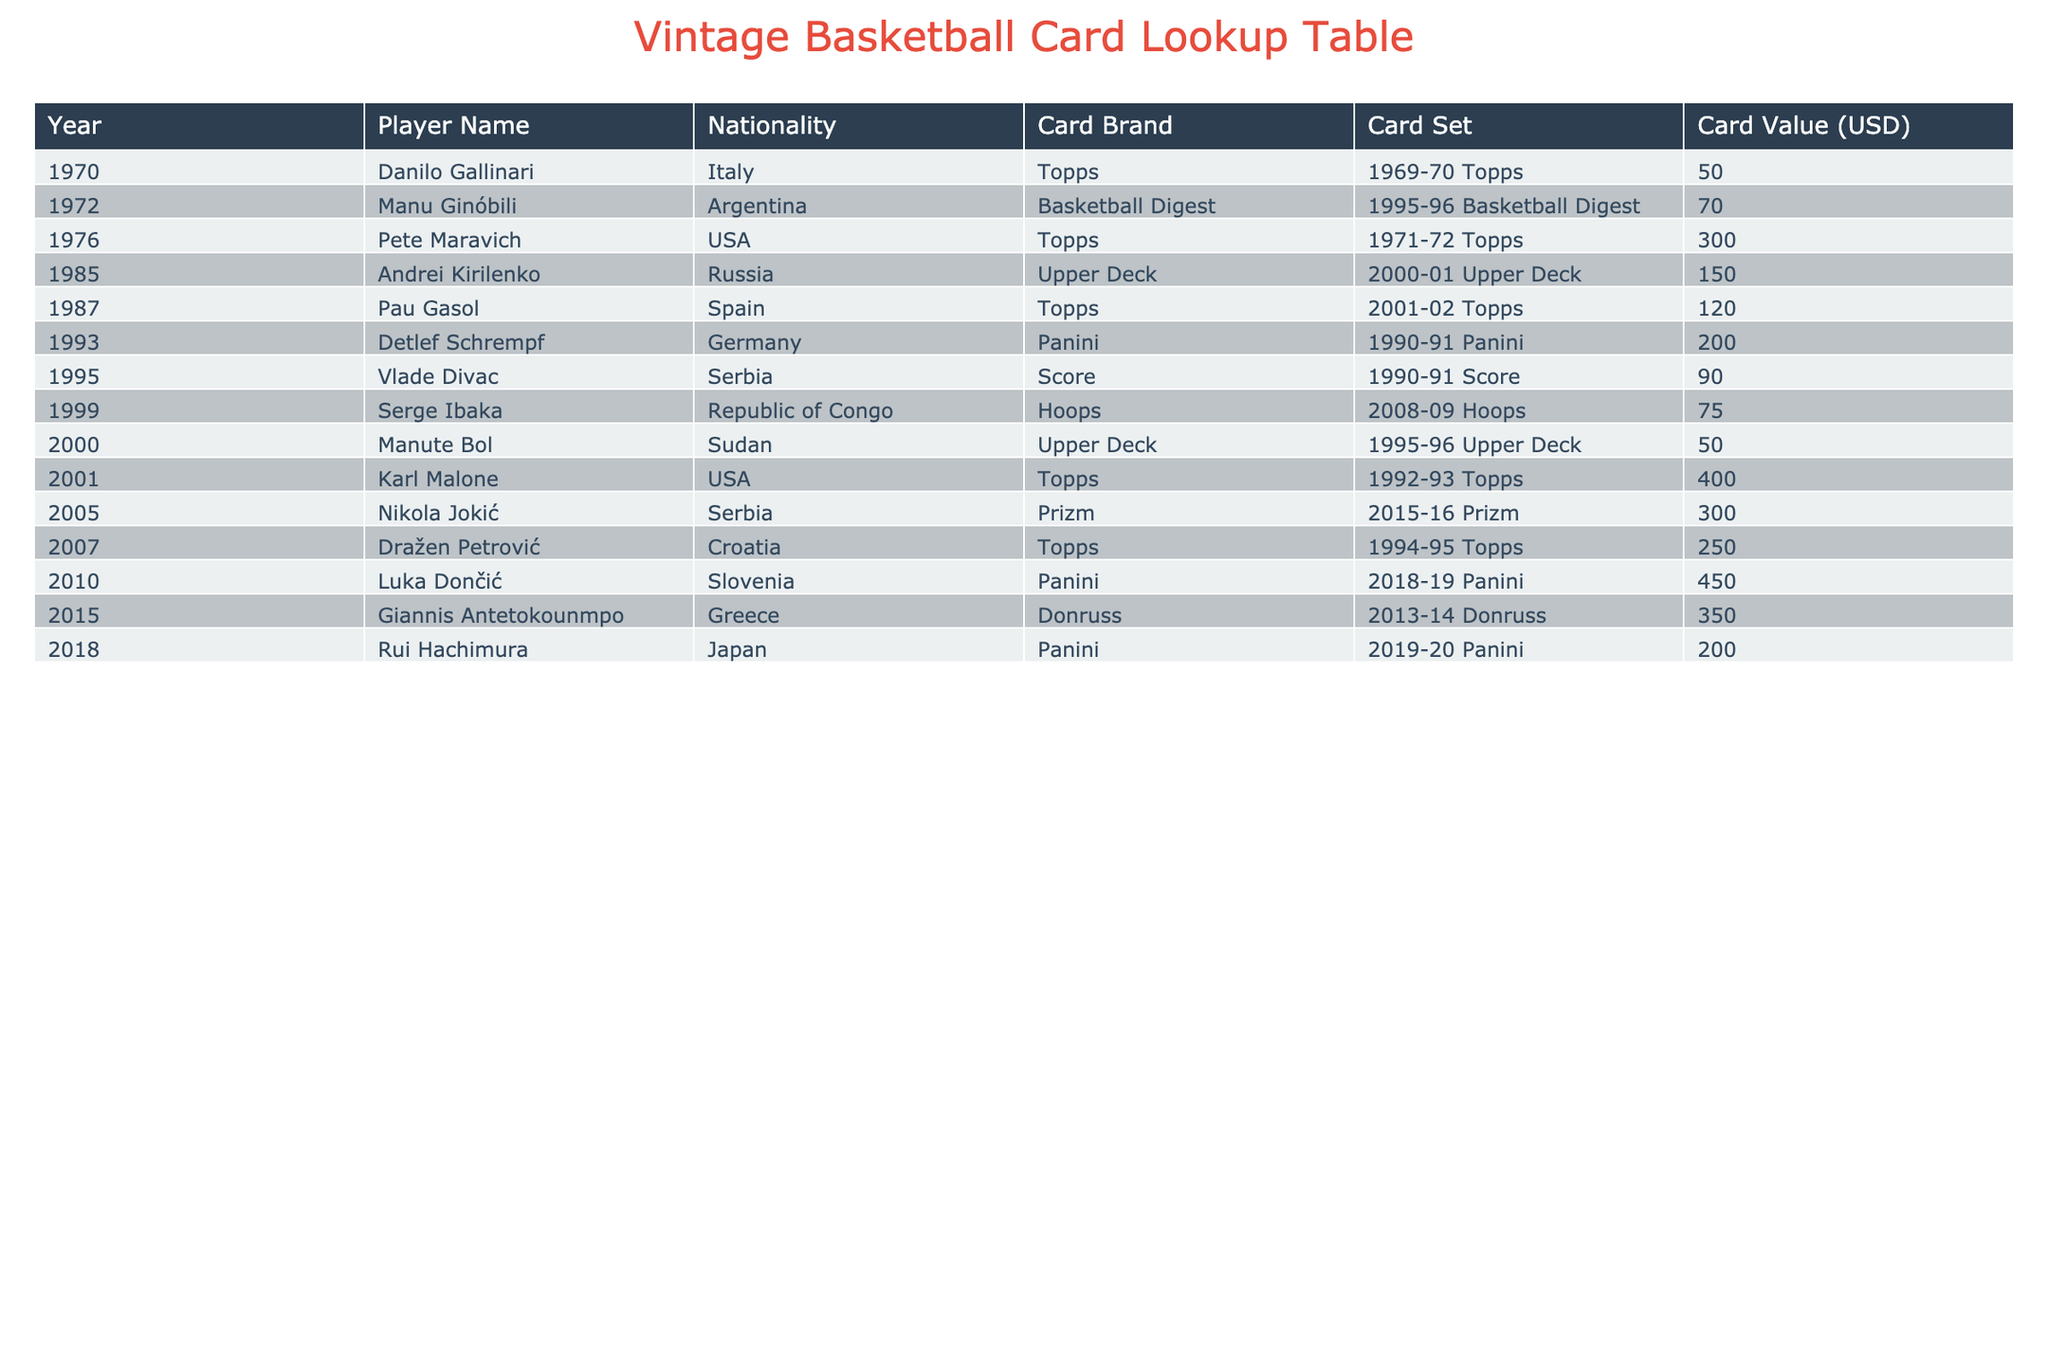What is the highest card value among international players? The highest card value from international players is found by looking at the "Card Value (USD)" column and identifying the maximum value. The highest value listed is 450 for Luka Dončić in 2010.
Answer: 450 Which player has the lowest card value in the table? To find the lowest card value, we can scan the "Card Value (USD)" column and identify the minimum value. The lowest value is 50, associated with Danilo Gallinari and Manute Bol.
Answer: 50 How many players from Serbia are in the table, and what are their card values? By examining the "Nationality" column, we find there are two players from Serbia: Vlade Divac with a card value of 90 and Nikola Jokić with a card value of 300.
Answer: 2 players: Vlade Divac (90), Nikola Jokić (300) What is the total value of the cards from players representing countries in Europe? We can filter the table for players from European countries and sum their card values: Andrei Kirilenko (150), Pau Gasol (120), Detlef Schrempf (200), Vlade Divac (90), Dražen Petrović (250), Luka Dončić (450), Giannis Antetokounmpo (350). The total is 150 + 120 + 200 + 90 + 250 + 450 + 350 = 1,610.
Answer: 1610 Is the card value of Rui Hachimura higher than that of Manu Ginóbili? By checking the "Card Value (USD)" for Rui Hachimura (200) and Manu Ginóbili (70), we see that 200 is greater than 70. Therefore, Rui Hachimura's card value is higher.
Answer: Yes 